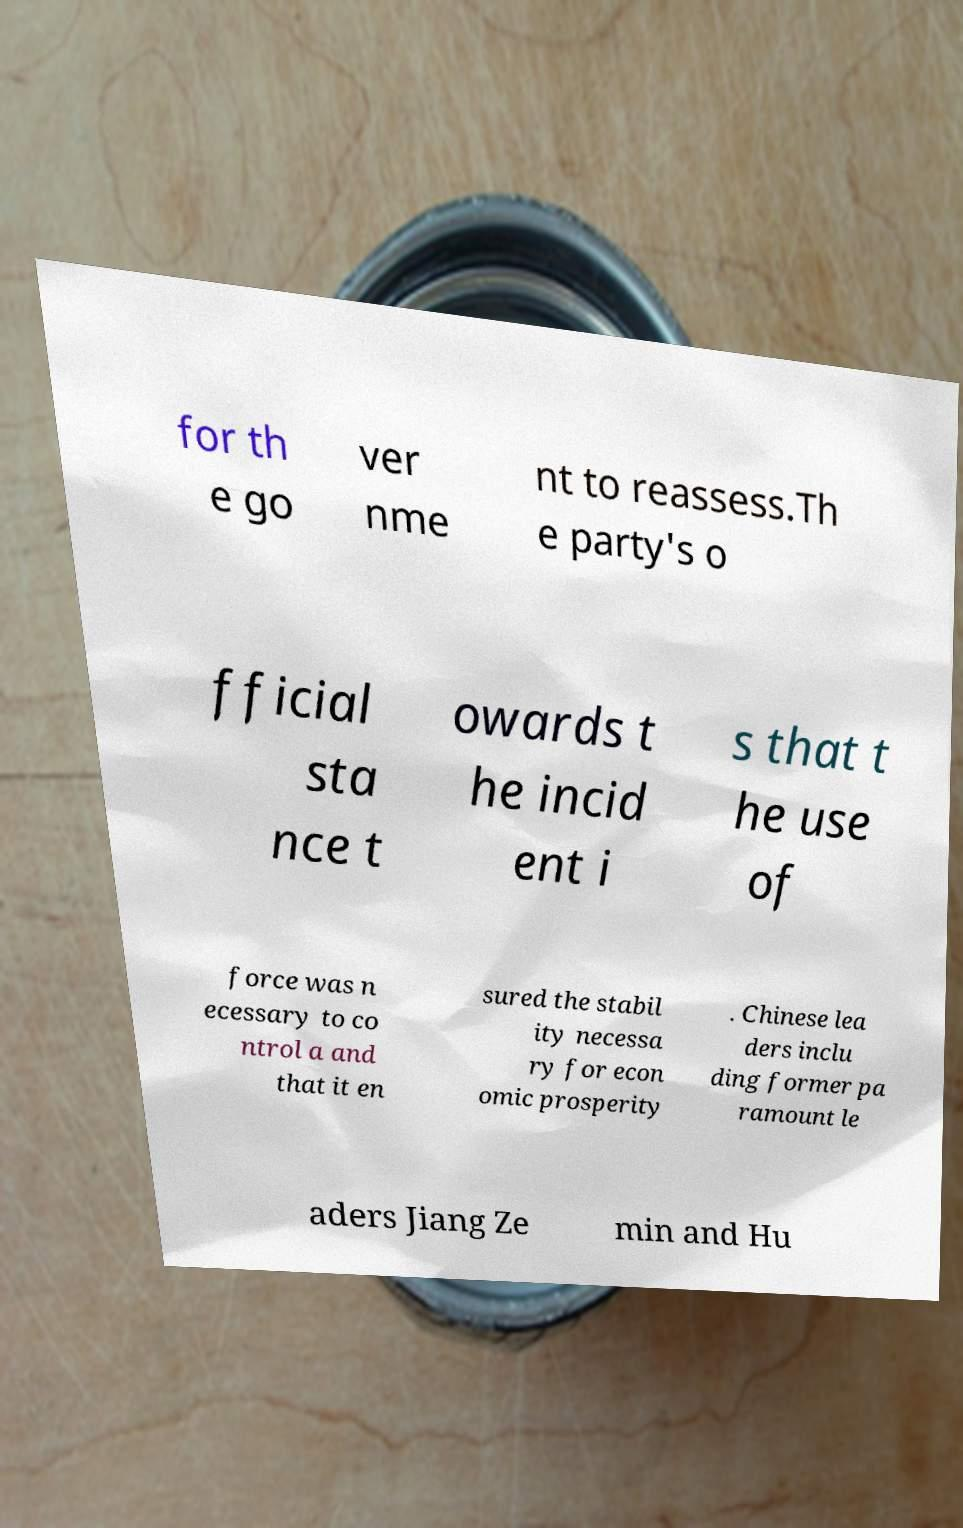Please read and relay the text visible in this image. What does it say? for th e go ver nme nt to reassess.Th e party's o fficial sta nce t owards t he incid ent i s that t he use of force was n ecessary to co ntrol a and that it en sured the stabil ity necessa ry for econ omic prosperity . Chinese lea ders inclu ding former pa ramount le aders Jiang Ze min and Hu 